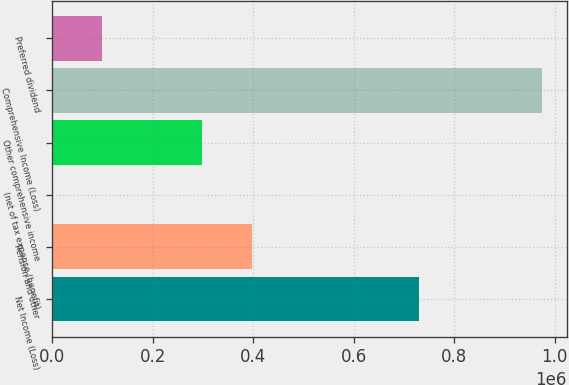Convert chart. <chart><loc_0><loc_0><loc_500><loc_500><bar_chart><fcel>Net Income (Loss)<fcel>Pension and other<fcel>(net of tax expense (benefit)<fcel>Other comprehensive income<fcel>Comprehensive Income (Loss)<fcel>Preferred dividend<nl><fcel>730572<fcel>397878<fcel>243<fcel>298469<fcel>975661<fcel>99651.8<nl></chart> 